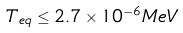<formula> <loc_0><loc_0><loc_500><loc_500>T _ { e q } \leq 2 . 7 \times 1 0 ^ { - 6 } M e V</formula> 